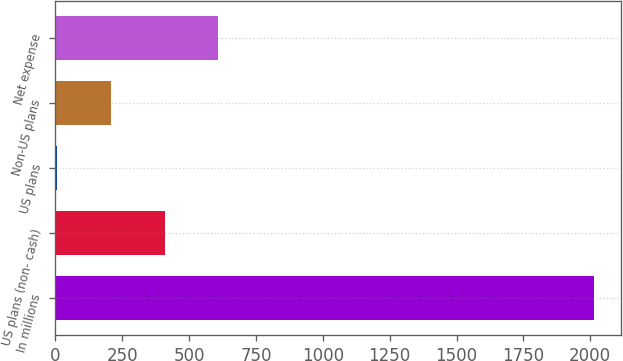<chart> <loc_0><loc_0><loc_500><loc_500><bar_chart><fcel>In millions<fcel>US plans (non- cash)<fcel>US plans<fcel>Non-US plans<fcel>Net expense<nl><fcel>2014<fcel>408.4<fcel>7<fcel>207.7<fcel>609.1<nl></chart> 